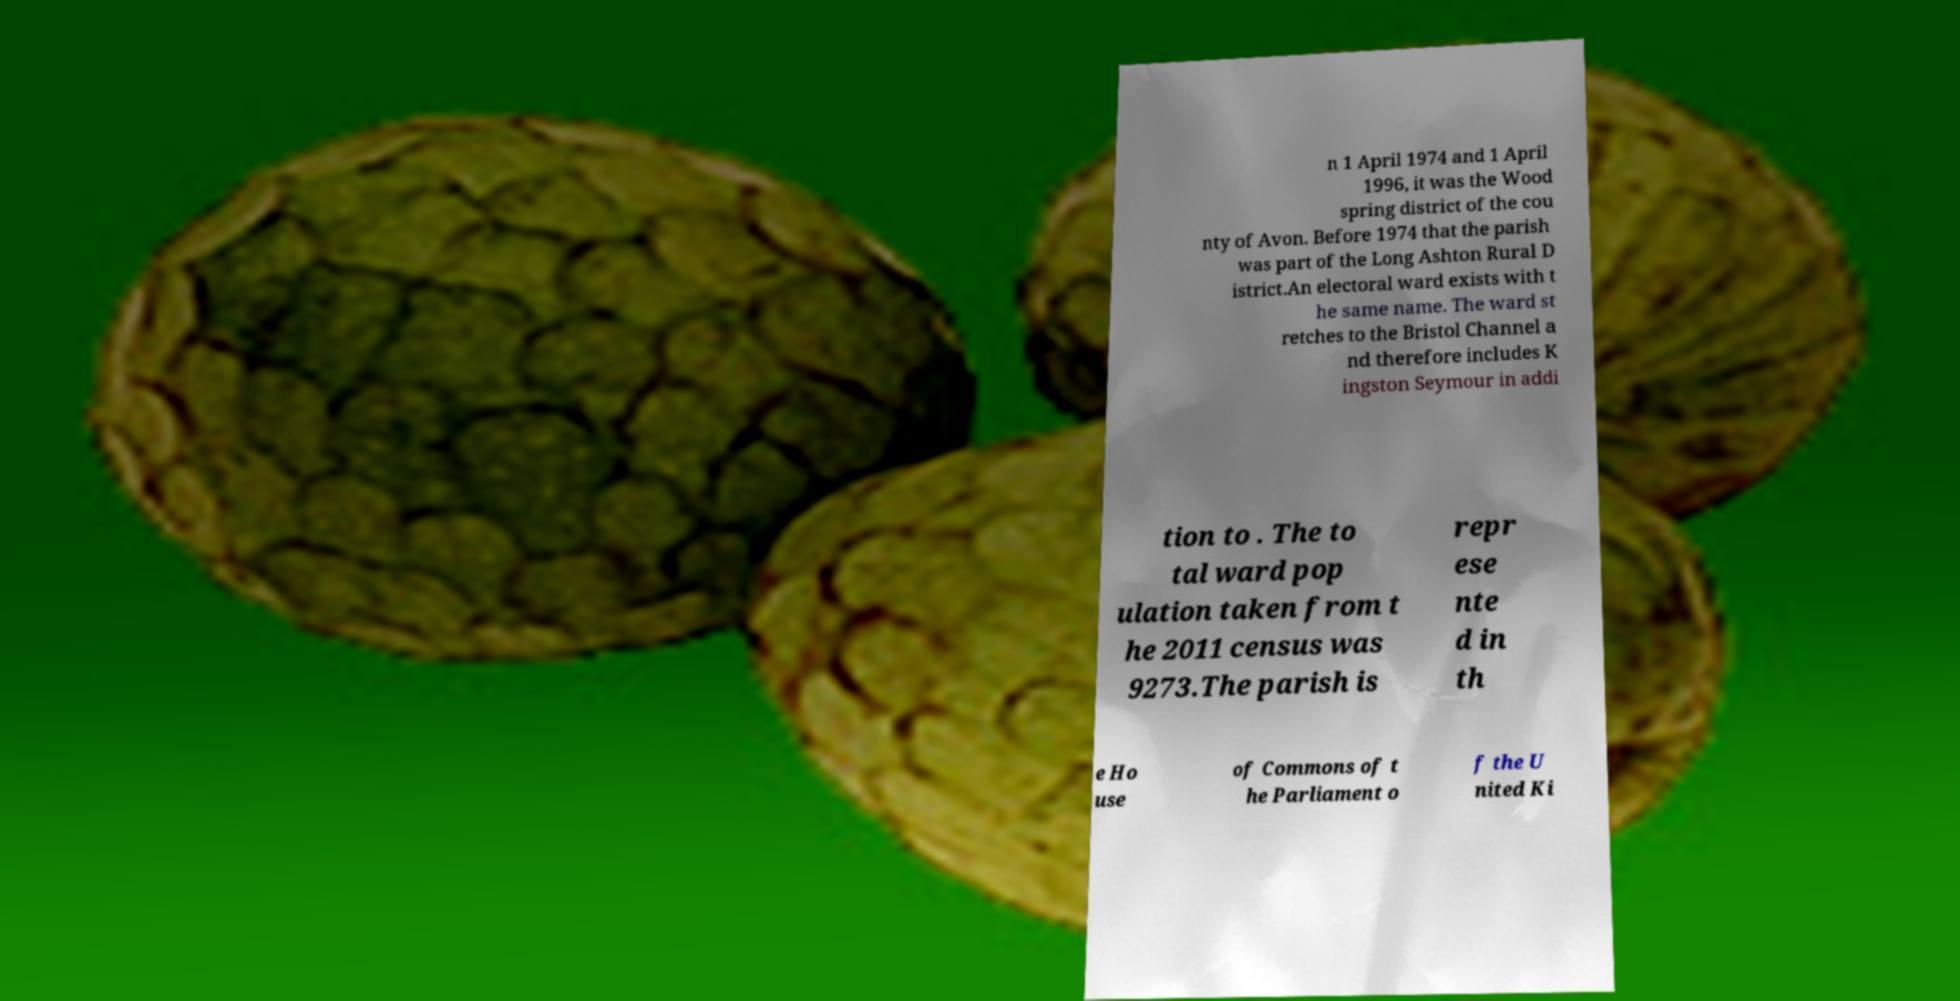For documentation purposes, I need the text within this image transcribed. Could you provide that? n 1 April 1974 and 1 April 1996, it was the Wood spring district of the cou nty of Avon. Before 1974 that the parish was part of the Long Ashton Rural D istrict.An electoral ward exists with t he same name. The ward st retches to the Bristol Channel a nd therefore includes K ingston Seymour in addi tion to . The to tal ward pop ulation taken from t he 2011 census was 9273.The parish is repr ese nte d in th e Ho use of Commons of t he Parliament o f the U nited Ki 